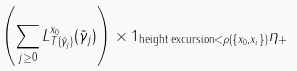<formula> <loc_0><loc_0><loc_500><loc_500>\left ( \sum _ { j \geq 0 } L ^ { x _ { 0 } } _ { T ( \tilde { \gamma } _ { j } ) } ( \tilde { \gamma } _ { j } ) \right ) \times 1 _ { \text {height excursion} < \rho ( \{ x _ { 0 } , x _ { i } \} ) } \eta _ { + }</formula> 